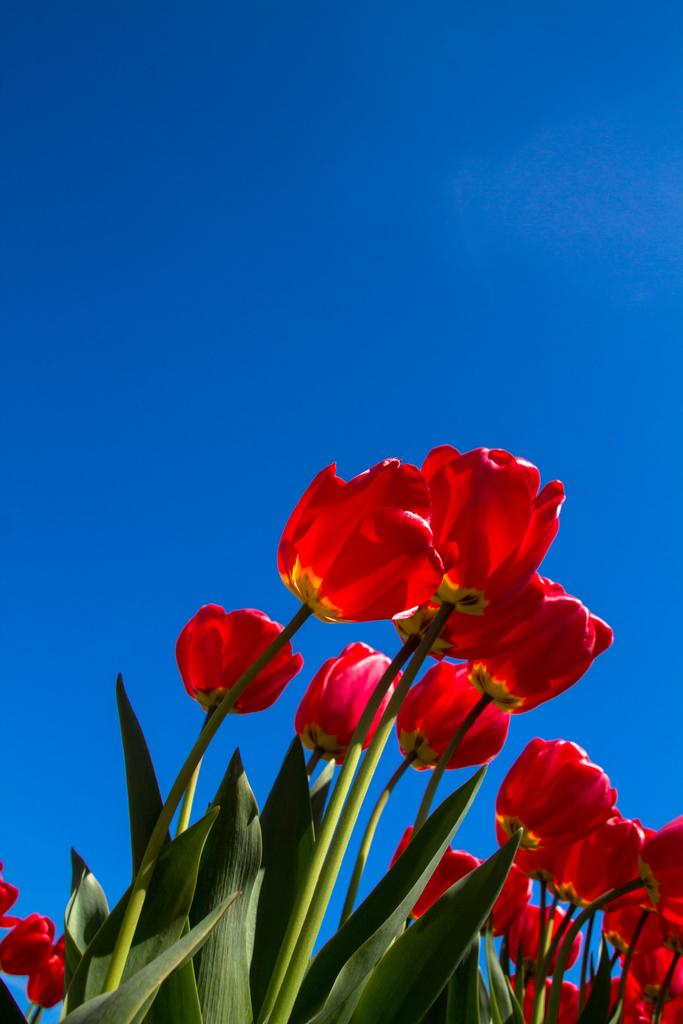What type of flowers can be seen in the image? There are tulip flowers in the image. What else is present in the image besides the flowers? There are plants in the image. What can be seen in the background of the image? The sky is visible in the background of the image. Can you see any rats running around in the image? There are no rats present in the image. What type of air transportation can be seen in the image? There is no air transportation present in the image. 